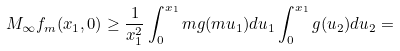Convert formula to latex. <formula><loc_0><loc_0><loc_500><loc_500>M _ { \infty } f _ { m } ( x _ { 1 } , 0 ) \geq \frac { 1 } { x _ { 1 } ^ { 2 } } \int _ { 0 } ^ { x _ { 1 } } m g ( m u _ { 1 } ) d u _ { 1 } \int _ { 0 } ^ { x _ { 1 } } g ( u _ { 2 } ) d u _ { 2 } =</formula> 